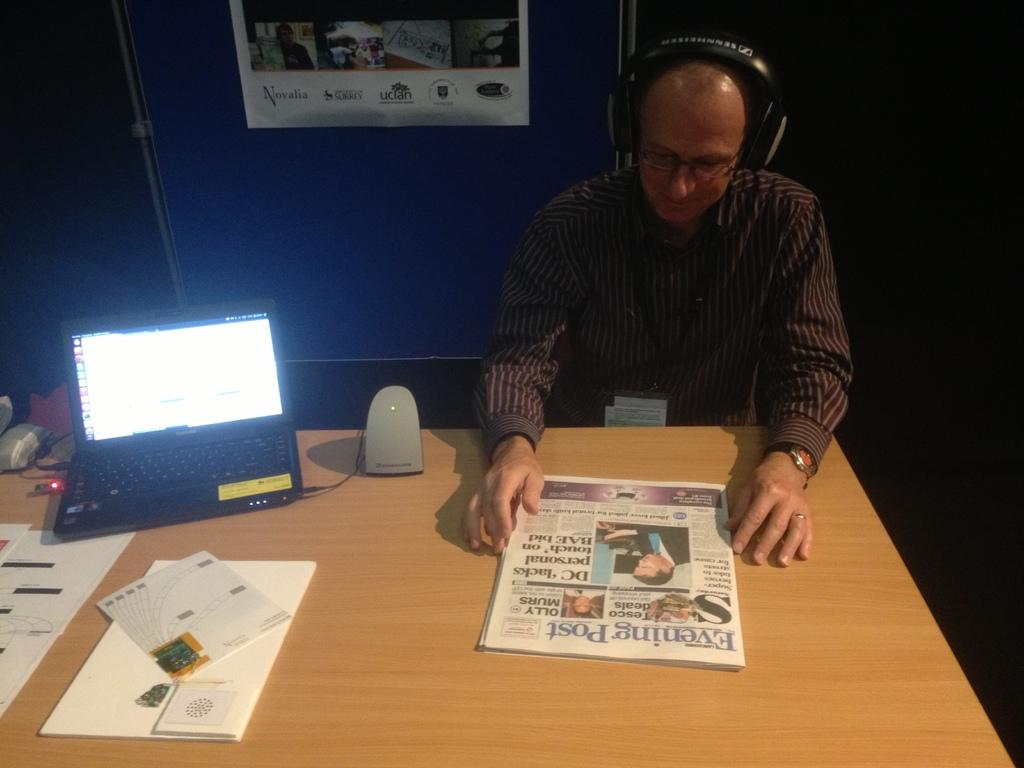Provide a one-sentence caption for the provided image. a man reading a newspaper that is titled 'evening post'. 